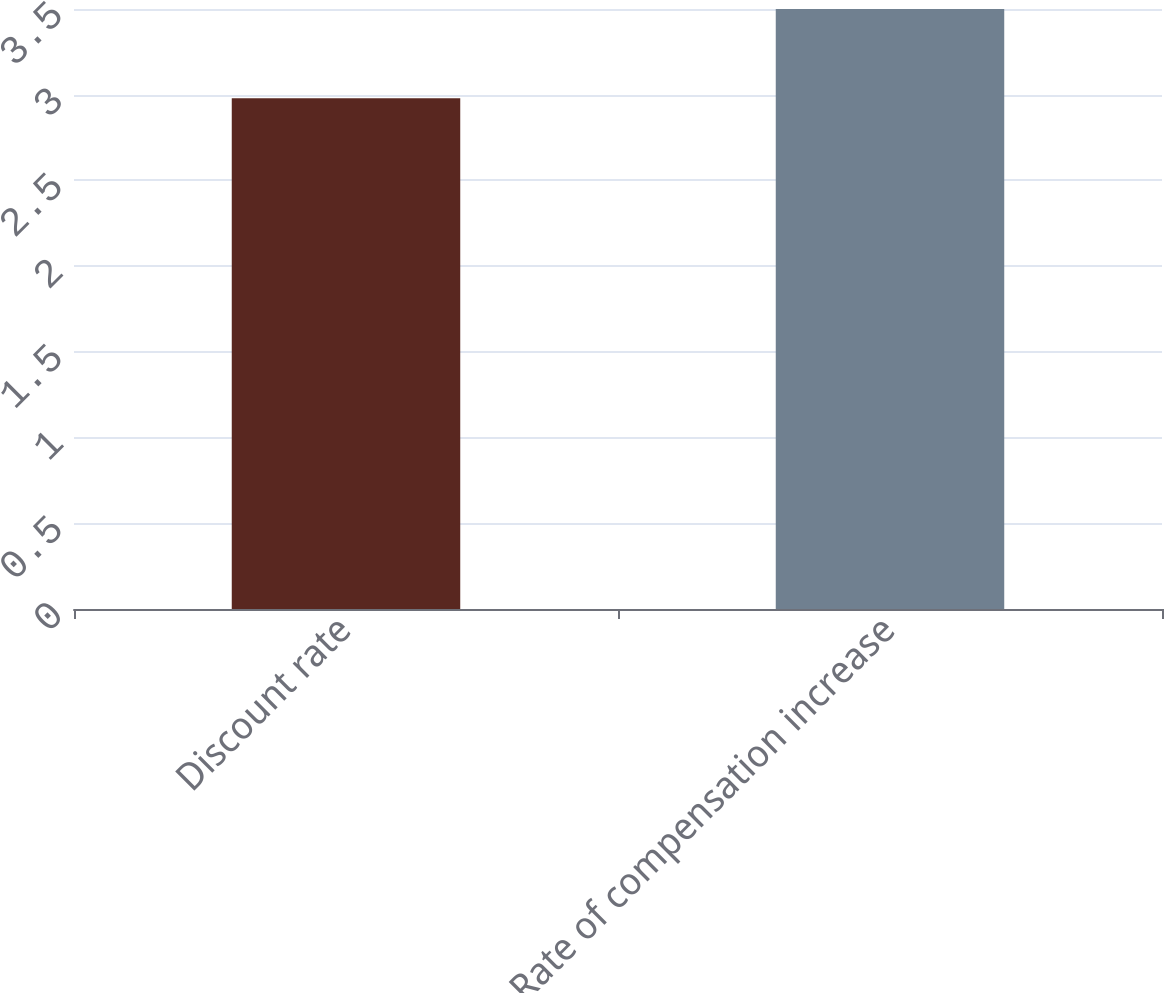Convert chart. <chart><loc_0><loc_0><loc_500><loc_500><bar_chart><fcel>Discount rate<fcel>Rate of compensation increase<nl><fcel>2.98<fcel>3.5<nl></chart> 